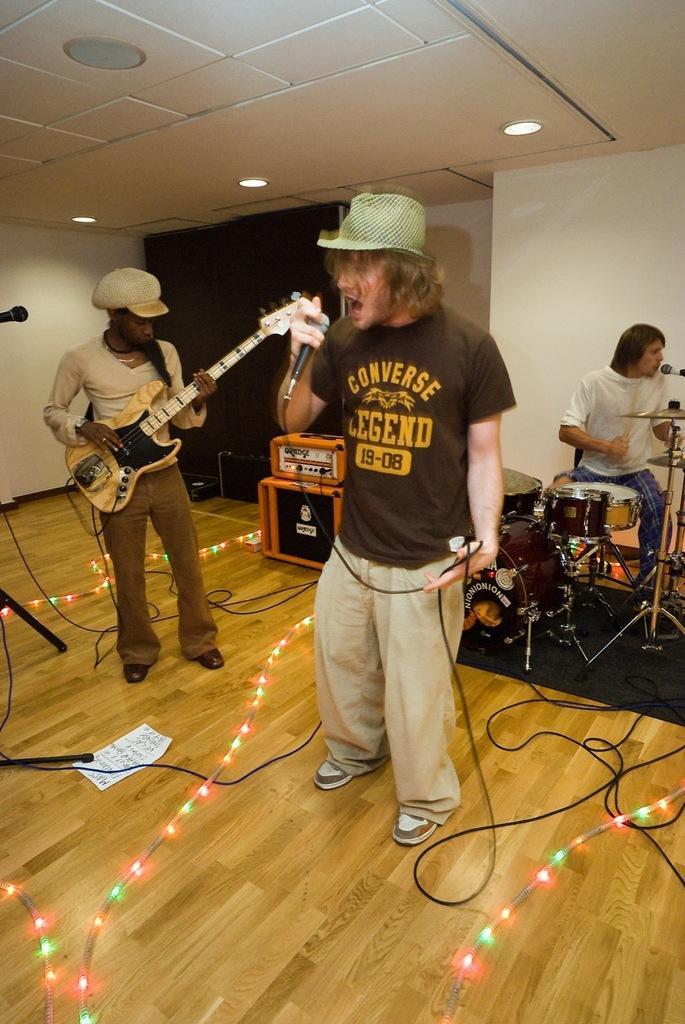Could you give a brief overview of what you see in this image? In the picture we can see a man singing a song in the microphone, he is wearing a black T-shirt, in the background we can see a person holding a guitar and playing it and other person is playing a orchestra and he is wearing a white T-shirt, in the background we can see a white wall with orange sound boxes and to the ceiling they are lights. 